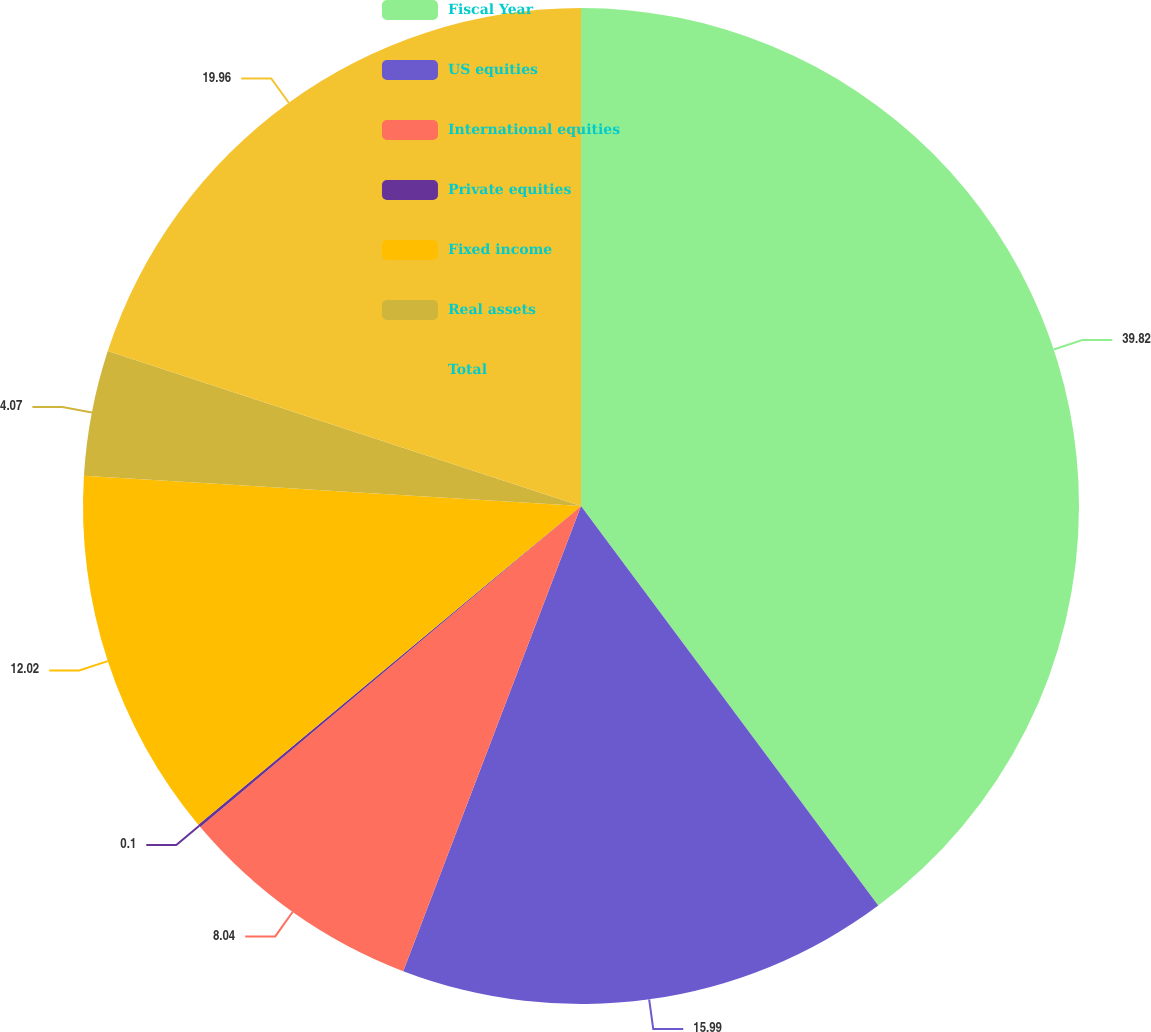<chart> <loc_0><loc_0><loc_500><loc_500><pie_chart><fcel>Fiscal Year<fcel>US equities<fcel>International equities<fcel>Private equities<fcel>Fixed income<fcel>Real assets<fcel>Total<nl><fcel>39.82%<fcel>15.99%<fcel>8.04%<fcel>0.1%<fcel>12.02%<fcel>4.07%<fcel>19.96%<nl></chart> 